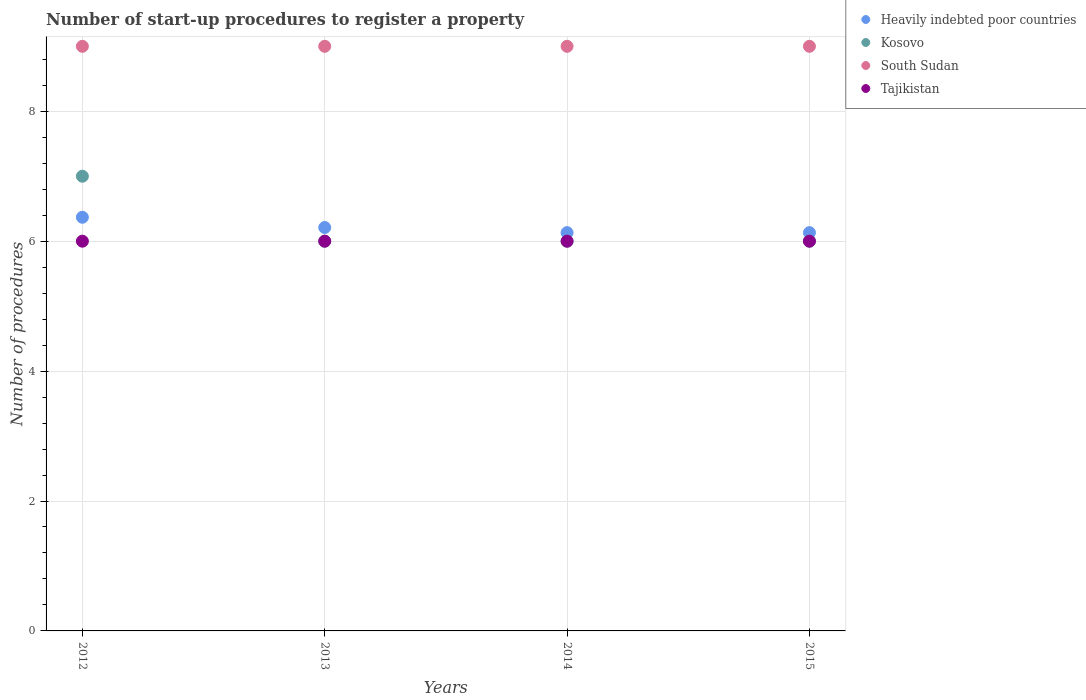Is the number of dotlines equal to the number of legend labels?
Provide a short and direct response. Yes. What is the number of procedures required to register a property in Kosovo in 2012?
Your answer should be compact. 7. In which year was the number of procedures required to register a property in Tajikistan maximum?
Keep it short and to the point. 2012. In which year was the number of procedures required to register a property in Tajikistan minimum?
Keep it short and to the point. 2012. What is the total number of procedures required to register a property in Kosovo in the graph?
Ensure brevity in your answer.  25. What is the difference between the number of procedures required to register a property in Heavily indebted poor countries in 2014 and the number of procedures required to register a property in South Sudan in 2012?
Your answer should be compact. -2.87. What is the ratio of the number of procedures required to register a property in Heavily indebted poor countries in 2012 to that in 2014?
Your answer should be compact. 1.04. What is the difference between the highest and the lowest number of procedures required to register a property in Heavily indebted poor countries?
Make the answer very short. 0.24. In how many years, is the number of procedures required to register a property in Heavily indebted poor countries greater than the average number of procedures required to register a property in Heavily indebted poor countries taken over all years?
Your answer should be very brief. 1. Is the sum of the number of procedures required to register a property in Kosovo in 2012 and 2014 greater than the maximum number of procedures required to register a property in Tajikistan across all years?
Make the answer very short. Yes. Is the number of procedures required to register a property in Tajikistan strictly greater than the number of procedures required to register a property in Kosovo over the years?
Provide a succinct answer. No. Is the number of procedures required to register a property in Kosovo strictly less than the number of procedures required to register a property in Tajikistan over the years?
Offer a terse response. No. How many years are there in the graph?
Your answer should be compact. 4. What is the difference between two consecutive major ticks on the Y-axis?
Your response must be concise. 2. Where does the legend appear in the graph?
Your answer should be very brief. Top right. How many legend labels are there?
Offer a very short reply. 4. What is the title of the graph?
Offer a terse response. Number of start-up procedures to register a property. What is the label or title of the Y-axis?
Give a very brief answer. Number of procedures. What is the Number of procedures of Heavily indebted poor countries in 2012?
Your answer should be very brief. 6.37. What is the Number of procedures in Tajikistan in 2012?
Your response must be concise. 6. What is the Number of procedures in Heavily indebted poor countries in 2013?
Your answer should be compact. 6.21. What is the Number of procedures of Kosovo in 2013?
Keep it short and to the point. 6. What is the Number of procedures in South Sudan in 2013?
Offer a terse response. 9. What is the Number of procedures of Heavily indebted poor countries in 2014?
Offer a terse response. 6.13. What is the Number of procedures of Tajikistan in 2014?
Provide a succinct answer. 6. What is the Number of procedures in Heavily indebted poor countries in 2015?
Ensure brevity in your answer.  6.13. What is the Number of procedures of Tajikistan in 2015?
Ensure brevity in your answer.  6. Across all years, what is the maximum Number of procedures in Heavily indebted poor countries?
Provide a succinct answer. 6.37. Across all years, what is the maximum Number of procedures of Kosovo?
Offer a terse response. 7. Across all years, what is the maximum Number of procedures in South Sudan?
Your answer should be compact. 9. Across all years, what is the minimum Number of procedures in Heavily indebted poor countries?
Give a very brief answer. 6.13. Across all years, what is the minimum Number of procedures of Kosovo?
Provide a succinct answer. 6. What is the total Number of procedures in Heavily indebted poor countries in the graph?
Keep it short and to the point. 24.84. What is the difference between the Number of procedures in Heavily indebted poor countries in 2012 and that in 2013?
Make the answer very short. 0.16. What is the difference between the Number of procedures of Tajikistan in 2012 and that in 2013?
Your answer should be compact. 0. What is the difference between the Number of procedures of Heavily indebted poor countries in 2012 and that in 2014?
Provide a short and direct response. 0.24. What is the difference between the Number of procedures in Kosovo in 2012 and that in 2014?
Offer a very short reply. 1. What is the difference between the Number of procedures of Tajikistan in 2012 and that in 2014?
Give a very brief answer. 0. What is the difference between the Number of procedures of Heavily indebted poor countries in 2012 and that in 2015?
Give a very brief answer. 0.24. What is the difference between the Number of procedures in Kosovo in 2012 and that in 2015?
Your answer should be compact. 1. What is the difference between the Number of procedures in Tajikistan in 2012 and that in 2015?
Make the answer very short. 0. What is the difference between the Number of procedures of Heavily indebted poor countries in 2013 and that in 2014?
Ensure brevity in your answer.  0.08. What is the difference between the Number of procedures of Kosovo in 2013 and that in 2014?
Give a very brief answer. 0. What is the difference between the Number of procedures in Heavily indebted poor countries in 2013 and that in 2015?
Provide a succinct answer. 0.08. What is the difference between the Number of procedures in Tajikistan in 2013 and that in 2015?
Provide a short and direct response. 0. What is the difference between the Number of procedures in Heavily indebted poor countries in 2014 and that in 2015?
Make the answer very short. 0. What is the difference between the Number of procedures of Heavily indebted poor countries in 2012 and the Number of procedures of Kosovo in 2013?
Provide a short and direct response. 0.37. What is the difference between the Number of procedures in Heavily indebted poor countries in 2012 and the Number of procedures in South Sudan in 2013?
Your answer should be very brief. -2.63. What is the difference between the Number of procedures in Heavily indebted poor countries in 2012 and the Number of procedures in Tajikistan in 2013?
Your answer should be compact. 0.37. What is the difference between the Number of procedures of Heavily indebted poor countries in 2012 and the Number of procedures of Kosovo in 2014?
Provide a short and direct response. 0.37. What is the difference between the Number of procedures of Heavily indebted poor countries in 2012 and the Number of procedures of South Sudan in 2014?
Provide a succinct answer. -2.63. What is the difference between the Number of procedures in Heavily indebted poor countries in 2012 and the Number of procedures in Tajikistan in 2014?
Offer a terse response. 0.37. What is the difference between the Number of procedures of Kosovo in 2012 and the Number of procedures of Tajikistan in 2014?
Provide a succinct answer. 1. What is the difference between the Number of procedures in South Sudan in 2012 and the Number of procedures in Tajikistan in 2014?
Offer a terse response. 3. What is the difference between the Number of procedures in Heavily indebted poor countries in 2012 and the Number of procedures in Kosovo in 2015?
Offer a very short reply. 0.37. What is the difference between the Number of procedures in Heavily indebted poor countries in 2012 and the Number of procedures in South Sudan in 2015?
Offer a terse response. -2.63. What is the difference between the Number of procedures in Heavily indebted poor countries in 2012 and the Number of procedures in Tajikistan in 2015?
Provide a short and direct response. 0.37. What is the difference between the Number of procedures of Kosovo in 2012 and the Number of procedures of South Sudan in 2015?
Your response must be concise. -2. What is the difference between the Number of procedures in Kosovo in 2012 and the Number of procedures in Tajikistan in 2015?
Keep it short and to the point. 1. What is the difference between the Number of procedures of Heavily indebted poor countries in 2013 and the Number of procedures of Kosovo in 2014?
Offer a very short reply. 0.21. What is the difference between the Number of procedures of Heavily indebted poor countries in 2013 and the Number of procedures of South Sudan in 2014?
Your answer should be compact. -2.79. What is the difference between the Number of procedures in Heavily indebted poor countries in 2013 and the Number of procedures in Tajikistan in 2014?
Ensure brevity in your answer.  0.21. What is the difference between the Number of procedures of Kosovo in 2013 and the Number of procedures of South Sudan in 2014?
Make the answer very short. -3. What is the difference between the Number of procedures of Kosovo in 2013 and the Number of procedures of Tajikistan in 2014?
Your answer should be compact. 0. What is the difference between the Number of procedures of South Sudan in 2013 and the Number of procedures of Tajikistan in 2014?
Offer a very short reply. 3. What is the difference between the Number of procedures in Heavily indebted poor countries in 2013 and the Number of procedures in Kosovo in 2015?
Ensure brevity in your answer.  0.21. What is the difference between the Number of procedures in Heavily indebted poor countries in 2013 and the Number of procedures in South Sudan in 2015?
Offer a very short reply. -2.79. What is the difference between the Number of procedures in Heavily indebted poor countries in 2013 and the Number of procedures in Tajikistan in 2015?
Your answer should be very brief. 0.21. What is the difference between the Number of procedures in Kosovo in 2013 and the Number of procedures in Tajikistan in 2015?
Provide a succinct answer. 0. What is the difference between the Number of procedures in Heavily indebted poor countries in 2014 and the Number of procedures in Kosovo in 2015?
Keep it short and to the point. 0.13. What is the difference between the Number of procedures in Heavily indebted poor countries in 2014 and the Number of procedures in South Sudan in 2015?
Make the answer very short. -2.87. What is the difference between the Number of procedures in Heavily indebted poor countries in 2014 and the Number of procedures in Tajikistan in 2015?
Keep it short and to the point. 0.13. What is the difference between the Number of procedures in Kosovo in 2014 and the Number of procedures in South Sudan in 2015?
Your response must be concise. -3. What is the difference between the Number of procedures of Kosovo in 2014 and the Number of procedures of Tajikistan in 2015?
Ensure brevity in your answer.  0. What is the average Number of procedures of Heavily indebted poor countries per year?
Offer a terse response. 6.21. What is the average Number of procedures in Kosovo per year?
Your answer should be compact. 6.25. What is the average Number of procedures in South Sudan per year?
Your response must be concise. 9. What is the average Number of procedures in Tajikistan per year?
Ensure brevity in your answer.  6. In the year 2012, what is the difference between the Number of procedures of Heavily indebted poor countries and Number of procedures of Kosovo?
Ensure brevity in your answer.  -0.63. In the year 2012, what is the difference between the Number of procedures in Heavily indebted poor countries and Number of procedures in South Sudan?
Provide a short and direct response. -2.63. In the year 2012, what is the difference between the Number of procedures of Heavily indebted poor countries and Number of procedures of Tajikistan?
Provide a short and direct response. 0.37. In the year 2012, what is the difference between the Number of procedures in Kosovo and Number of procedures in South Sudan?
Your answer should be very brief. -2. In the year 2012, what is the difference between the Number of procedures in Kosovo and Number of procedures in Tajikistan?
Offer a very short reply. 1. In the year 2013, what is the difference between the Number of procedures in Heavily indebted poor countries and Number of procedures in Kosovo?
Make the answer very short. 0.21. In the year 2013, what is the difference between the Number of procedures of Heavily indebted poor countries and Number of procedures of South Sudan?
Offer a very short reply. -2.79. In the year 2013, what is the difference between the Number of procedures of Heavily indebted poor countries and Number of procedures of Tajikistan?
Ensure brevity in your answer.  0.21. In the year 2013, what is the difference between the Number of procedures of Kosovo and Number of procedures of South Sudan?
Provide a short and direct response. -3. In the year 2013, what is the difference between the Number of procedures of South Sudan and Number of procedures of Tajikistan?
Your answer should be compact. 3. In the year 2014, what is the difference between the Number of procedures in Heavily indebted poor countries and Number of procedures in Kosovo?
Provide a succinct answer. 0.13. In the year 2014, what is the difference between the Number of procedures in Heavily indebted poor countries and Number of procedures in South Sudan?
Ensure brevity in your answer.  -2.87. In the year 2014, what is the difference between the Number of procedures in Heavily indebted poor countries and Number of procedures in Tajikistan?
Give a very brief answer. 0.13. In the year 2014, what is the difference between the Number of procedures of Kosovo and Number of procedures of South Sudan?
Provide a succinct answer. -3. In the year 2014, what is the difference between the Number of procedures in Kosovo and Number of procedures in Tajikistan?
Give a very brief answer. 0. In the year 2014, what is the difference between the Number of procedures in South Sudan and Number of procedures in Tajikistan?
Give a very brief answer. 3. In the year 2015, what is the difference between the Number of procedures in Heavily indebted poor countries and Number of procedures in Kosovo?
Your answer should be compact. 0.13. In the year 2015, what is the difference between the Number of procedures of Heavily indebted poor countries and Number of procedures of South Sudan?
Ensure brevity in your answer.  -2.87. In the year 2015, what is the difference between the Number of procedures of Heavily indebted poor countries and Number of procedures of Tajikistan?
Offer a very short reply. 0.13. In the year 2015, what is the difference between the Number of procedures in Kosovo and Number of procedures in South Sudan?
Your answer should be compact. -3. In the year 2015, what is the difference between the Number of procedures in Kosovo and Number of procedures in Tajikistan?
Make the answer very short. 0. What is the ratio of the Number of procedures of Heavily indebted poor countries in 2012 to that in 2013?
Provide a succinct answer. 1.03. What is the ratio of the Number of procedures of Tajikistan in 2012 to that in 2013?
Offer a terse response. 1. What is the ratio of the Number of procedures in Heavily indebted poor countries in 2012 to that in 2014?
Give a very brief answer. 1.04. What is the ratio of the Number of procedures of Tajikistan in 2012 to that in 2014?
Keep it short and to the point. 1. What is the ratio of the Number of procedures in Heavily indebted poor countries in 2012 to that in 2015?
Provide a short and direct response. 1.04. What is the ratio of the Number of procedures in Kosovo in 2012 to that in 2015?
Offer a terse response. 1.17. What is the ratio of the Number of procedures of Tajikistan in 2012 to that in 2015?
Keep it short and to the point. 1. What is the ratio of the Number of procedures of Heavily indebted poor countries in 2013 to that in 2014?
Give a very brief answer. 1.01. What is the ratio of the Number of procedures in Kosovo in 2013 to that in 2014?
Provide a short and direct response. 1. What is the ratio of the Number of procedures of Tajikistan in 2013 to that in 2014?
Make the answer very short. 1. What is the ratio of the Number of procedures in Heavily indebted poor countries in 2013 to that in 2015?
Ensure brevity in your answer.  1.01. What is the ratio of the Number of procedures in Kosovo in 2014 to that in 2015?
Give a very brief answer. 1. What is the ratio of the Number of procedures in South Sudan in 2014 to that in 2015?
Provide a succinct answer. 1. What is the ratio of the Number of procedures in Tajikistan in 2014 to that in 2015?
Ensure brevity in your answer.  1. What is the difference between the highest and the second highest Number of procedures of Heavily indebted poor countries?
Provide a succinct answer. 0.16. What is the difference between the highest and the second highest Number of procedures in Tajikistan?
Your answer should be very brief. 0. What is the difference between the highest and the lowest Number of procedures in Heavily indebted poor countries?
Ensure brevity in your answer.  0.24. What is the difference between the highest and the lowest Number of procedures in South Sudan?
Offer a very short reply. 0. 